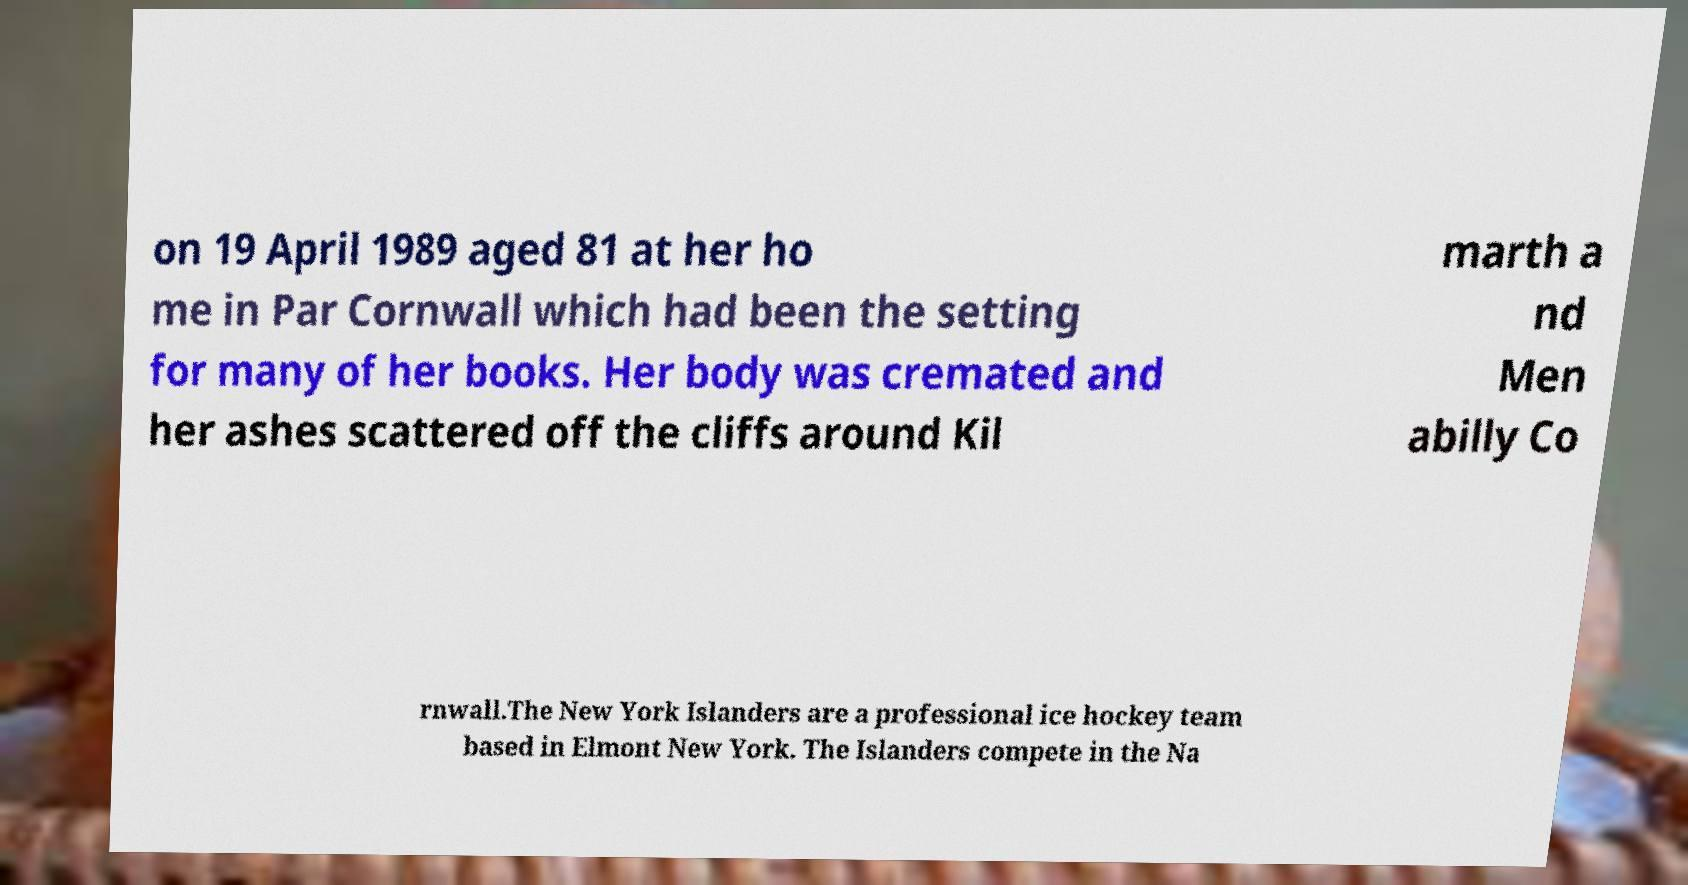Please read and relay the text visible in this image. What does it say? on 19 April 1989 aged 81 at her ho me in Par Cornwall which had been the setting for many of her books. Her body was cremated and her ashes scattered off the cliffs around Kil marth a nd Men abilly Co rnwall.The New York Islanders are a professional ice hockey team based in Elmont New York. The Islanders compete in the Na 